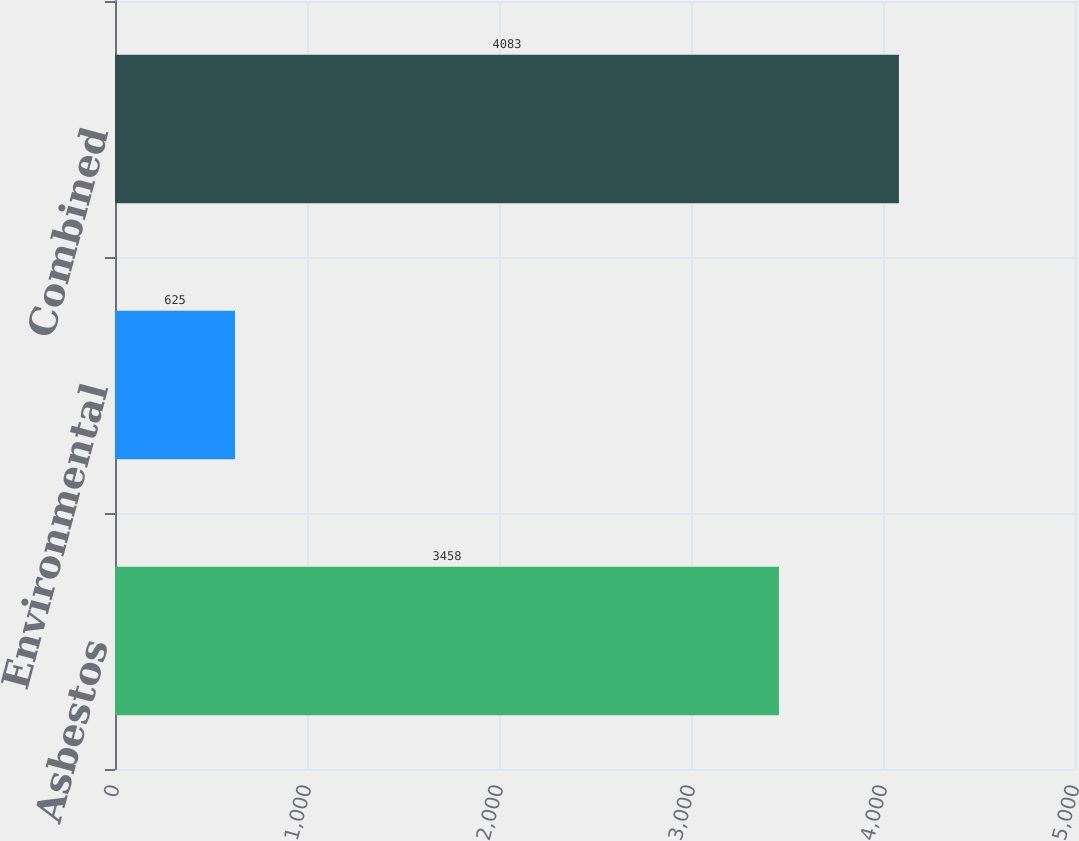Convert chart to OTSL. <chart><loc_0><loc_0><loc_500><loc_500><bar_chart><fcel>Asbestos<fcel>Environmental<fcel>Combined<nl><fcel>3458<fcel>625<fcel>4083<nl></chart> 